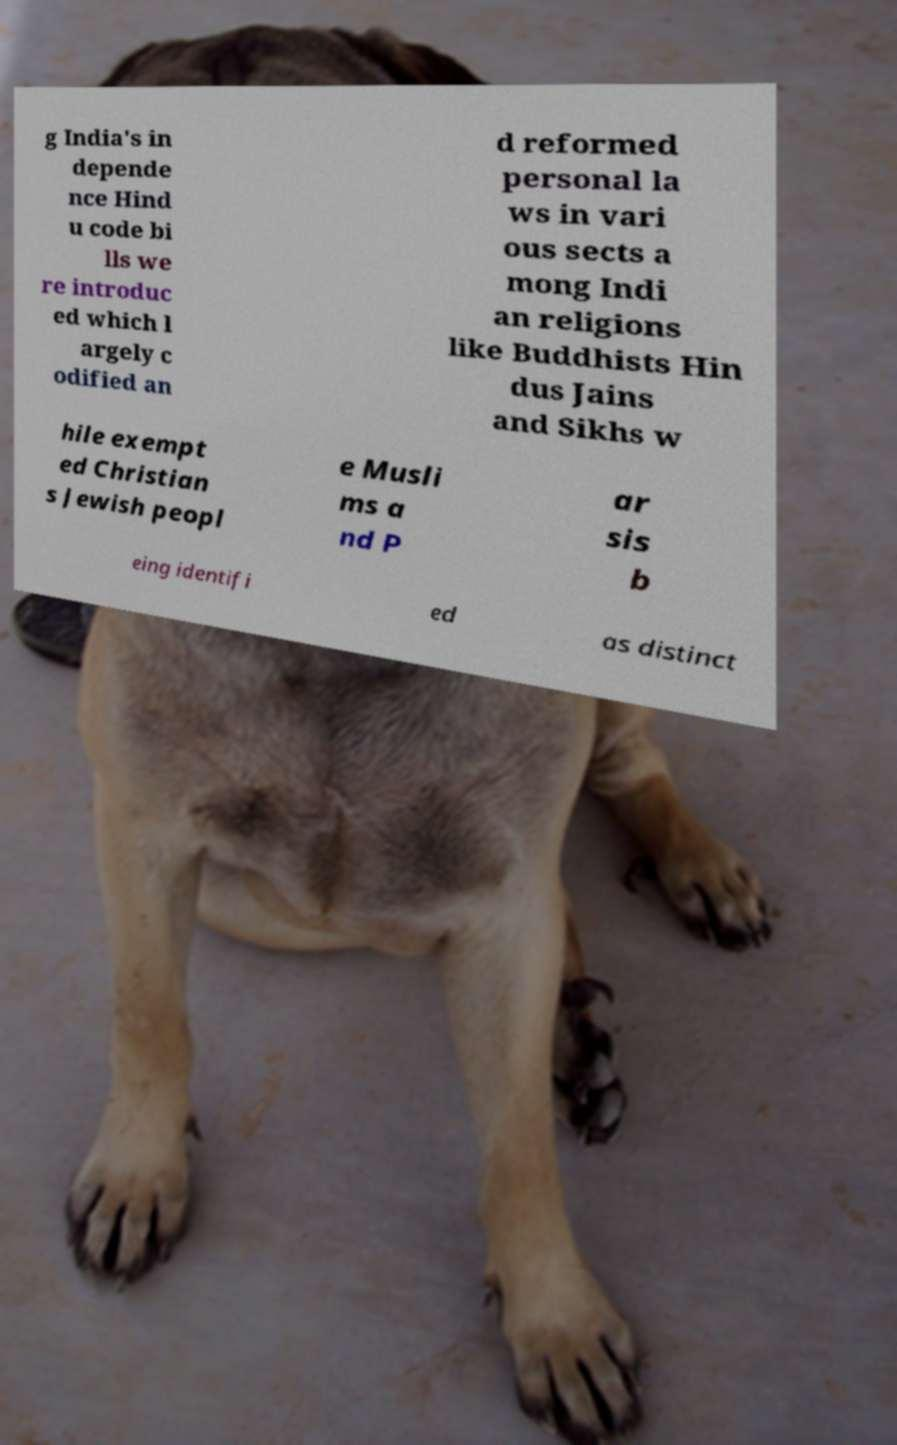There's text embedded in this image that I need extracted. Can you transcribe it verbatim? g India's in depende nce Hind u code bi lls we re introduc ed which l argely c odified an d reformed personal la ws in vari ous sects a mong Indi an religions like Buddhists Hin dus Jains and Sikhs w hile exempt ed Christian s Jewish peopl e Musli ms a nd P ar sis b eing identifi ed as distinct 